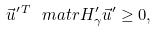<formula> <loc_0><loc_0><loc_500><loc_500>\vec { u } ^ { \prime \, T } \ m a t r { H } _ { \gamma } ^ { \prime } \vec { u } ^ { \prime } \geq 0 ,</formula> 